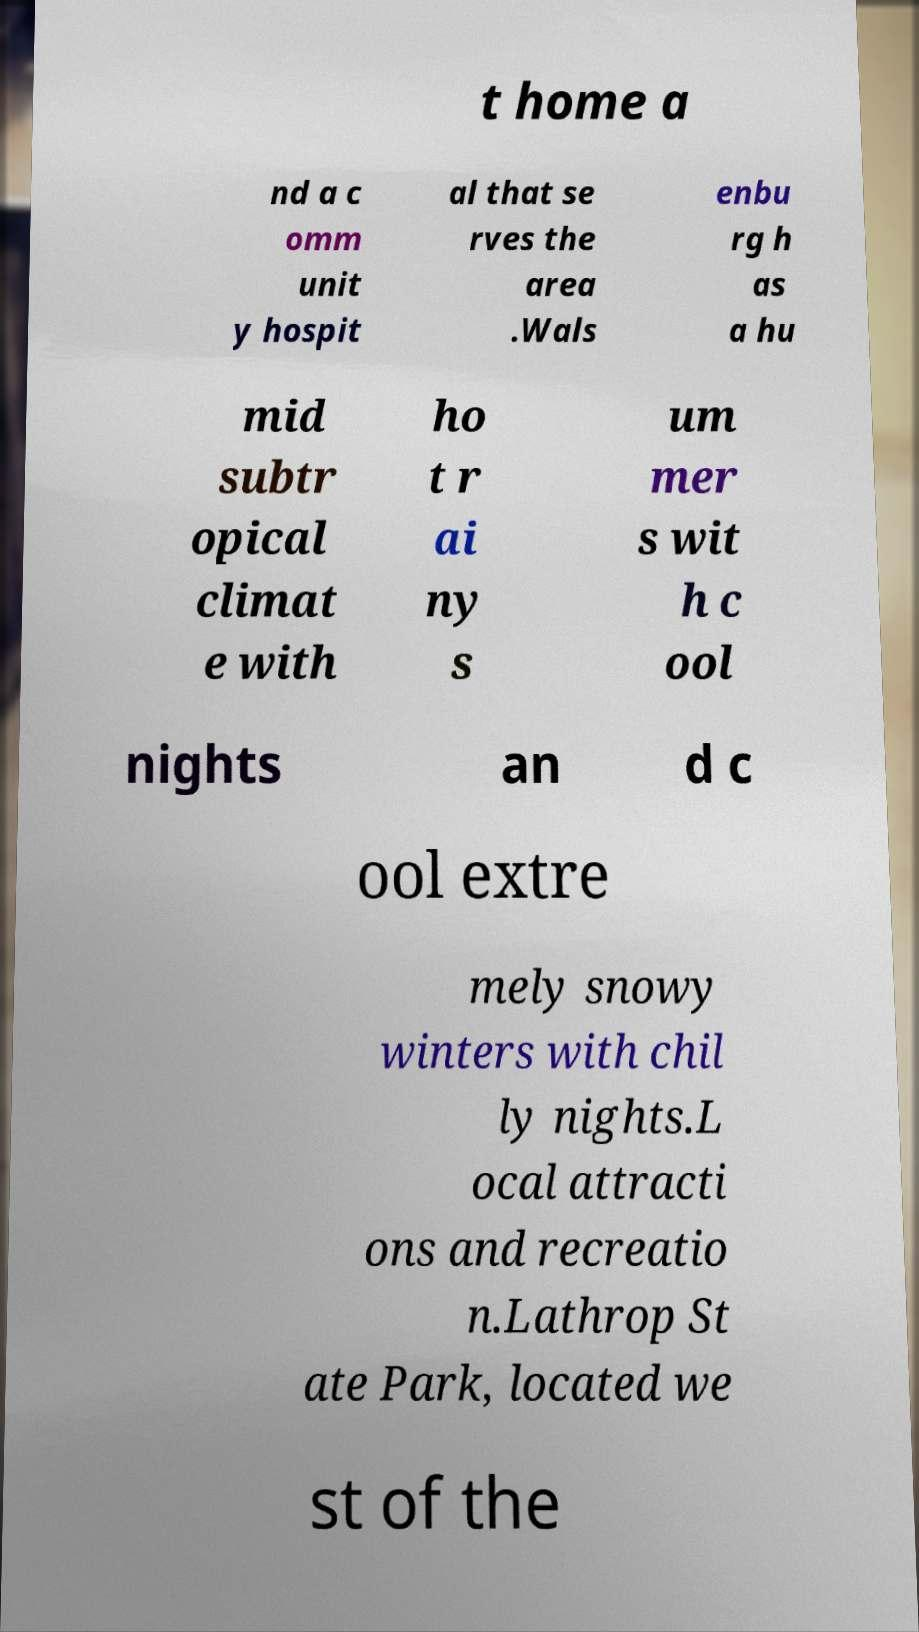Please identify and transcribe the text found in this image. t home a nd a c omm unit y hospit al that se rves the area .Wals enbu rg h as a hu mid subtr opical climat e with ho t r ai ny s um mer s wit h c ool nights an d c ool extre mely snowy winters with chil ly nights.L ocal attracti ons and recreatio n.Lathrop St ate Park, located we st of the 